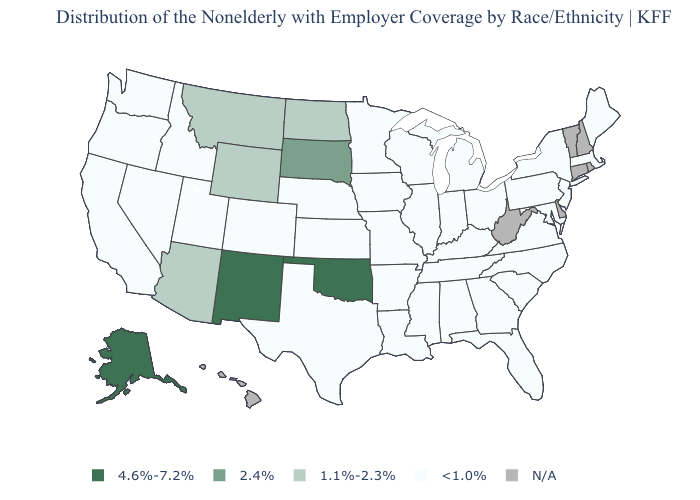Is the legend a continuous bar?
Be succinct. No. What is the value of North Carolina?
Give a very brief answer. <1.0%. Which states have the lowest value in the West?
Concise answer only. California, Colorado, Idaho, Nevada, Oregon, Utah, Washington. Does Texas have the highest value in the South?
Give a very brief answer. No. Name the states that have a value in the range 2.4%?
Give a very brief answer. South Dakota. What is the lowest value in the MidWest?
Short answer required. <1.0%. Which states have the lowest value in the USA?
Quick response, please. Alabama, Arkansas, California, Colorado, Florida, Georgia, Idaho, Illinois, Indiana, Iowa, Kansas, Kentucky, Louisiana, Maine, Maryland, Massachusetts, Michigan, Minnesota, Mississippi, Missouri, Nebraska, Nevada, New Jersey, New York, North Carolina, Ohio, Oregon, Pennsylvania, South Carolina, Tennessee, Texas, Utah, Virginia, Washington, Wisconsin. Does South Dakota have the highest value in the MidWest?
Keep it brief. Yes. Name the states that have a value in the range 2.4%?
Give a very brief answer. South Dakota. Name the states that have a value in the range <1.0%?
Concise answer only. Alabama, Arkansas, California, Colorado, Florida, Georgia, Idaho, Illinois, Indiana, Iowa, Kansas, Kentucky, Louisiana, Maine, Maryland, Massachusetts, Michigan, Minnesota, Mississippi, Missouri, Nebraska, Nevada, New Jersey, New York, North Carolina, Ohio, Oregon, Pennsylvania, South Carolina, Tennessee, Texas, Utah, Virginia, Washington, Wisconsin. Name the states that have a value in the range 2.4%?
Keep it brief. South Dakota. What is the value of Montana?
Write a very short answer. 1.1%-2.3%. 